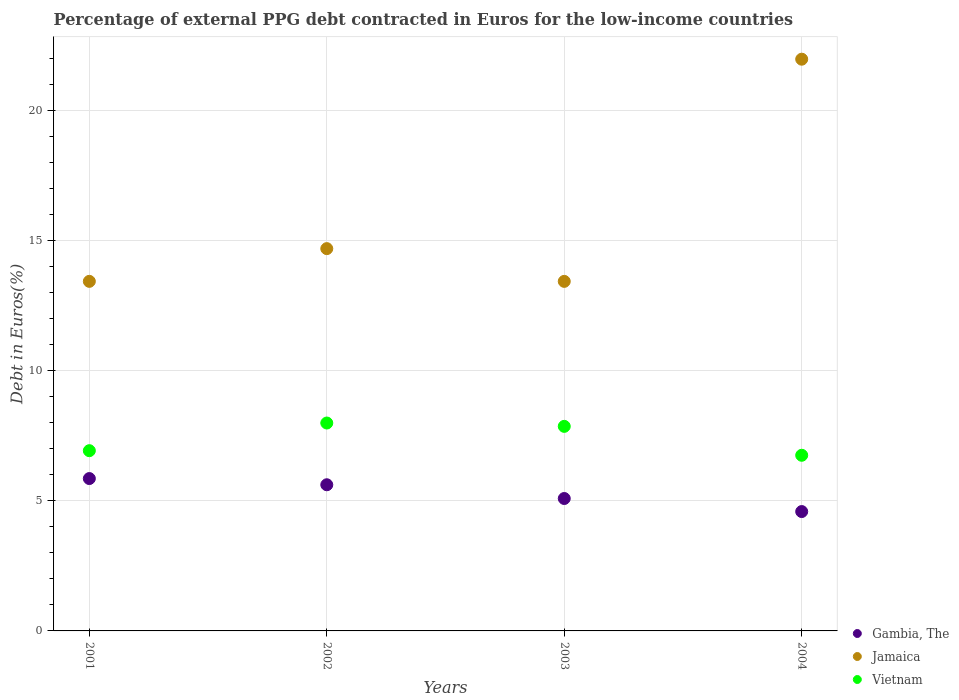Is the number of dotlines equal to the number of legend labels?
Your answer should be compact. Yes. What is the percentage of external PPG debt contracted in Euros in Vietnam in 2004?
Provide a succinct answer. 6.75. Across all years, what is the maximum percentage of external PPG debt contracted in Euros in Gambia, The?
Your response must be concise. 5.86. Across all years, what is the minimum percentage of external PPG debt contracted in Euros in Gambia, The?
Your response must be concise. 4.59. What is the total percentage of external PPG debt contracted in Euros in Jamaica in the graph?
Your answer should be very brief. 63.56. What is the difference between the percentage of external PPG debt contracted in Euros in Jamaica in 2002 and that in 2003?
Offer a terse response. 1.26. What is the difference between the percentage of external PPG debt contracted in Euros in Vietnam in 2004 and the percentage of external PPG debt contracted in Euros in Jamaica in 2001?
Make the answer very short. -6.69. What is the average percentage of external PPG debt contracted in Euros in Gambia, The per year?
Ensure brevity in your answer.  5.29. In the year 2001, what is the difference between the percentage of external PPG debt contracted in Euros in Jamaica and percentage of external PPG debt contracted in Euros in Vietnam?
Offer a very short reply. 6.51. In how many years, is the percentage of external PPG debt contracted in Euros in Jamaica greater than 11 %?
Make the answer very short. 4. What is the ratio of the percentage of external PPG debt contracted in Euros in Jamaica in 2002 to that in 2003?
Keep it short and to the point. 1.09. Is the difference between the percentage of external PPG debt contracted in Euros in Jamaica in 2001 and 2003 greater than the difference between the percentage of external PPG debt contracted in Euros in Vietnam in 2001 and 2003?
Give a very brief answer. Yes. What is the difference between the highest and the second highest percentage of external PPG debt contracted in Euros in Gambia, The?
Your answer should be very brief. 0.24. What is the difference between the highest and the lowest percentage of external PPG debt contracted in Euros in Vietnam?
Ensure brevity in your answer.  1.24. In how many years, is the percentage of external PPG debt contracted in Euros in Vietnam greater than the average percentage of external PPG debt contracted in Euros in Vietnam taken over all years?
Offer a terse response. 2. Is the sum of the percentage of external PPG debt contracted in Euros in Vietnam in 2003 and 2004 greater than the maximum percentage of external PPG debt contracted in Euros in Jamaica across all years?
Offer a terse response. No. Does the percentage of external PPG debt contracted in Euros in Jamaica monotonically increase over the years?
Ensure brevity in your answer.  No. Is the percentage of external PPG debt contracted in Euros in Gambia, The strictly less than the percentage of external PPG debt contracted in Euros in Vietnam over the years?
Provide a short and direct response. Yes. Are the values on the major ticks of Y-axis written in scientific E-notation?
Give a very brief answer. No. Where does the legend appear in the graph?
Offer a very short reply. Bottom right. What is the title of the graph?
Ensure brevity in your answer.  Percentage of external PPG debt contracted in Euros for the low-income countries. What is the label or title of the X-axis?
Ensure brevity in your answer.  Years. What is the label or title of the Y-axis?
Ensure brevity in your answer.  Debt in Euros(%). What is the Debt in Euros(%) of Gambia, The in 2001?
Keep it short and to the point. 5.86. What is the Debt in Euros(%) of Jamaica in 2001?
Keep it short and to the point. 13.44. What is the Debt in Euros(%) in Vietnam in 2001?
Give a very brief answer. 6.93. What is the Debt in Euros(%) in Gambia, The in 2002?
Your answer should be very brief. 5.62. What is the Debt in Euros(%) in Jamaica in 2002?
Make the answer very short. 14.7. What is the Debt in Euros(%) in Vietnam in 2002?
Your response must be concise. 7.99. What is the Debt in Euros(%) of Gambia, The in 2003?
Give a very brief answer. 5.09. What is the Debt in Euros(%) of Jamaica in 2003?
Ensure brevity in your answer.  13.44. What is the Debt in Euros(%) of Vietnam in 2003?
Your answer should be compact. 7.87. What is the Debt in Euros(%) in Gambia, The in 2004?
Your answer should be compact. 4.59. What is the Debt in Euros(%) in Jamaica in 2004?
Ensure brevity in your answer.  21.98. What is the Debt in Euros(%) of Vietnam in 2004?
Keep it short and to the point. 6.75. Across all years, what is the maximum Debt in Euros(%) in Gambia, The?
Offer a terse response. 5.86. Across all years, what is the maximum Debt in Euros(%) of Jamaica?
Give a very brief answer. 21.98. Across all years, what is the maximum Debt in Euros(%) in Vietnam?
Keep it short and to the point. 7.99. Across all years, what is the minimum Debt in Euros(%) of Gambia, The?
Give a very brief answer. 4.59. Across all years, what is the minimum Debt in Euros(%) of Jamaica?
Provide a succinct answer. 13.44. Across all years, what is the minimum Debt in Euros(%) in Vietnam?
Provide a succinct answer. 6.75. What is the total Debt in Euros(%) of Gambia, The in the graph?
Your answer should be compact. 21.16. What is the total Debt in Euros(%) of Jamaica in the graph?
Make the answer very short. 63.56. What is the total Debt in Euros(%) of Vietnam in the graph?
Make the answer very short. 29.54. What is the difference between the Debt in Euros(%) of Gambia, The in 2001 and that in 2002?
Keep it short and to the point. 0.24. What is the difference between the Debt in Euros(%) of Jamaica in 2001 and that in 2002?
Your response must be concise. -1.26. What is the difference between the Debt in Euros(%) of Vietnam in 2001 and that in 2002?
Give a very brief answer. -1.06. What is the difference between the Debt in Euros(%) of Gambia, The in 2001 and that in 2003?
Your answer should be very brief. 0.77. What is the difference between the Debt in Euros(%) in Jamaica in 2001 and that in 2003?
Provide a succinct answer. 0. What is the difference between the Debt in Euros(%) of Vietnam in 2001 and that in 2003?
Your answer should be compact. -0.94. What is the difference between the Debt in Euros(%) in Gambia, The in 2001 and that in 2004?
Keep it short and to the point. 1.27. What is the difference between the Debt in Euros(%) of Jamaica in 2001 and that in 2004?
Provide a short and direct response. -8.54. What is the difference between the Debt in Euros(%) of Vietnam in 2001 and that in 2004?
Your response must be concise. 0.18. What is the difference between the Debt in Euros(%) of Gambia, The in 2002 and that in 2003?
Make the answer very short. 0.53. What is the difference between the Debt in Euros(%) in Jamaica in 2002 and that in 2003?
Give a very brief answer. 1.26. What is the difference between the Debt in Euros(%) in Vietnam in 2002 and that in 2003?
Keep it short and to the point. 0.13. What is the difference between the Debt in Euros(%) of Gambia, The in 2002 and that in 2004?
Your answer should be very brief. 1.03. What is the difference between the Debt in Euros(%) of Jamaica in 2002 and that in 2004?
Keep it short and to the point. -7.28. What is the difference between the Debt in Euros(%) of Vietnam in 2002 and that in 2004?
Offer a terse response. 1.24. What is the difference between the Debt in Euros(%) of Gambia, The in 2003 and that in 2004?
Make the answer very short. 0.5. What is the difference between the Debt in Euros(%) in Jamaica in 2003 and that in 2004?
Ensure brevity in your answer.  -8.54. What is the difference between the Debt in Euros(%) in Vietnam in 2003 and that in 2004?
Your answer should be compact. 1.11. What is the difference between the Debt in Euros(%) in Gambia, The in 2001 and the Debt in Euros(%) in Jamaica in 2002?
Your response must be concise. -8.84. What is the difference between the Debt in Euros(%) in Gambia, The in 2001 and the Debt in Euros(%) in Vietnam in 2002?
Provide a short and direct response. -2.14. What is the difference between the Debt in Euros(%) in Jamaica in 2001 and the Debt in Euros(%) in Vietnam in 2002?
Provide a short and direct response. 5.45. What is the difference between the Debt in Euros(%) of Gambia, The in 2001 and the Debt in Euros(%) of Jamaica in 2003?
Provide a short and direct response. -7.58. What is the difference between the Debt in Euros(%) of Gambia, The in 2001 and the Debt in Euros(%) of Vietnam in 2003?
Ensure brevity in your answer.  -2.01. What is the difference between the Debt in Euros(%) of Jamaica in 2001 and the Debt in Euros(%) of Vietnam in 2003?
Ensure brevity in your answer.  5.58. What is the difference between the Debt in Euros(%) in Gambia, The in 2001 and the Debt in Euros(%) in Jamaica in 2004?
Your answer should be very brief. -16.12. What is the difference between the Debt in Euros(%) of Gambia, The in 2001 and the Debt in Euros(%) of Vietnam in 2004?
Offer a terse response. -0.9. What is the difference between the Debt in Euros(%) in Jamaica in 2001 and the Debt in Euros(%) in Vietnam in 2004?
Keep it short and to the point. 6.69. What is the difference between the Debt in Euros(%) of Gambia, The in 2002 and the Debt in Euros(%) of Jamaica in 2003?
Your answer should be very brief. -7.82. What is the difference between the Debt in Euros(%) in Gambia, The in 2002 and the Debt in Euros(%) in Vietnam in 2003?
Offer a very short reply. -2.25. What is the difference between the Debt in Euros(%) of Jamaica in 2002 and the Debt in Euros(%) of Vietnam in 2003?
Offer a terse response. 6.83. What is the difference between the Debt in Euros(%) of Gambia, The in 2002 and the Debt in Euros(%) of Jamaica in 2004?
Your answer should be compact. -16.36. What is the difference between the Debt in Euros(%) of Gambia, The in 2002 and the Debt in Euros(%) of Vietnam in 2004?
Ensure brevity in your answer.  -1.13. What is the difference between the Debt in Euros(%) of Jamaica in 2002 and the Debt in Euros(%) of Vietnam in 2004?
Your response must be concise. 7.95. What is the difference between the Debt in Euros(%) in Gambia, The in 2003 and the Debt in Euros(%) in Jamaica in 2004?
Provide a short and direct response. -16.89. What is the difference between the Debt in Euros(%) in Gambia, The in 2003 and the Debt in Euros(%) in Vietnam in 2004?
Provide a short and direct response. -1.66. What is the difference between the Debt in Euros(%) in Jamaica in 2003 and the Debt in Euros(%) in Vietnam in 2004?
Your answer should be very brief. 6.69. What is the average Debt in Euros(%) of Gambia, The per year?
Offer a terse response. 5.29. What is the average Debt in Euros(%) in Jamaica per year?
Your answer should be very brief. 15.89. What is the average Debt in Euros(%) in Vietnam per year?
Give a very brief answer. 7.39. In the year 2001, what is the difference between the Debt in Euros(%) of Gambia, The and Debt in Euros(%) of Jamaica?
Keep it short and to the point. -7.58. In the year 2001, what is the difference between the Debt in Euros(%) of Gambia, The and Debt in Euros(%) of Vietnam?
Provide a succinct answer. -1.07. In the year 2001, what is the difference between the Debt in Euros(%) in Jamaica and Debt in Euros(%) in Vietnam?
Make the answer very short. 6.51. In the year 2002, what is the difference between the Debt in Euros(%) of Gambia, The and Debt in Euros(%) of Jamaica?
Your answer should be very brief. -9.08. In the year 2002, what is the difference between the Debt in Euros(%) in Gambia, The and Debt in Euros(%) in Vietnam?
Your response must be concise. -2.37. In the year 2002, what is the difference between the Debt in Euros(%) of Jamaica and Debt in Euros(%) of Vietnam?
Give a very brief answer. 6.71. In the year 2003, what is the difference between the Debt in Euros(%) in Gambia, The and Debt in Euros(%) in Jamaica?
Your answer should be compact. -8.35. In the year 2003, what is the difference between the Debt in Euros(%) of Gambia, The and Debt in Euros(%) of Vietnam?
Your answer should be compact. -2.77. In the year 2003, what is the difference between the Debt in Euros(%) of Jamaica and Debt in Euros(%) of Vietnam?
Keep it short and to the point. 5.57. In the year 2004, what is the difference between the Debt in Euros(%) of Gambia, The and Debt in Euros(%) of Jamaica?
Provide a succinct answer. -17.39. In the year 2004, what is the difference between the Debt in Euros(%) of Gambia, The and Debt in Euros(%) of Vietnam?
Give a very brief answer. -2.16. In the year 2004, what is the difference between the Debt in Euros(%) of Jamaica and Debt in Euros(%) of Vietnam?
Your answer should be very brief. 15.23. What is the ratio of the Debt in Euros(%) in Gambia, The in 2001 to that in 2002?
Make the answer very short. 1.04. What is the ratio of the Debt in Euros(%) of Jamaica in 2001 to that in 2002?
Provide a succinct answer. 0.91. What is the ratio of the Debt in Euros(%) of Vietnam in 2001 to that in 2002?
Ensure brevity in your answer.  0.87. What is the ratio of the Debt in Euros(%) in Gambia, The in 2001 to that in 2003?
Offer a terse response. 1.15. What is the ratio of the Debt in Euros(%) of Vietnam in 2001 to that in 2003?
Give a very brief answer. 0.88. What is the ratio of the Debt in Euros(%) of Gambia, The in 2001 to that in 2004?
Provide a short and direct response. 1.28. What is the ratio of the Debt in Euros(%) in Jamaica in 2001 to that in 2004?
Your response must be concise. 0.61. What is the ratio of the Debt in Euros(%) in Vietnam in 2001 to that in 2004?
Your answer should be very brief. 1.03. What is the ratio of the Debt in Euros(%) in Gambia, The in 2002 to that in 2003?
Provide a short and direct response. 1.1. What is the ratio of the Debt in Euros(%) in Jamaica in 2002 to that in 2003?
Your response must be concise. 1.09. What is the ratio of the Debt in Euros(%) in Vietnam in 2002 to that in 2003?
Offer a terse response. 1.02. What is the ratio of the Debt in Euros(%) of Gambia, The in 2002 to that in 2004?
Make the answer very short. 1.22. What is the ratio of the Debt in Euros(%) of Jamaica in 2002 to that in 2004?
Your answer should be compact. 0.67. What is the ratio of the Debt in Euros(%) of Vietnam in 2002 to that in 2004?
Ensure brevity in your answer.  1.18. What is the ratio of the Debt in Euros(%) in Gambia, The in 2003 to that in 2004?
Provide a succinct answer. 1.11. What is the ratio of the Debt in Euros(%) of Jamaica in 2003 to that in 2004?
Ensure brevity in your answer.  0.61. What is the ratio of the Debt in Euros(%) in Vietnam in 2003 to that in 2004?
Provide a short and direct response. 1.16. What is the difference between the highest and the second highest Debt in Euros(%) of Gambia, The?
Your response must be concise. 0.24. What is the difference between the highest and the second highest Debt in Euros(%) of Jamaica?
Give a very brief answer. 7.28. What is the difference between the highest and the second highest Debt in Euros(%) in Vietnam?
Provide a succinct answer. 0.13. What is the difference between the highest and the lowest Debt in Euros(%) in Gambia, The?
Keep it short and to the point. 1.27. What is the difference between the highest and the lowest Debt in Euros(%) in Jamaica?
Provide a succinct answer. 8.54. What is the difference between the highest and the lowest Debt in Euros(%) in Vietnam?
Give a very brief answer. 1.24. 